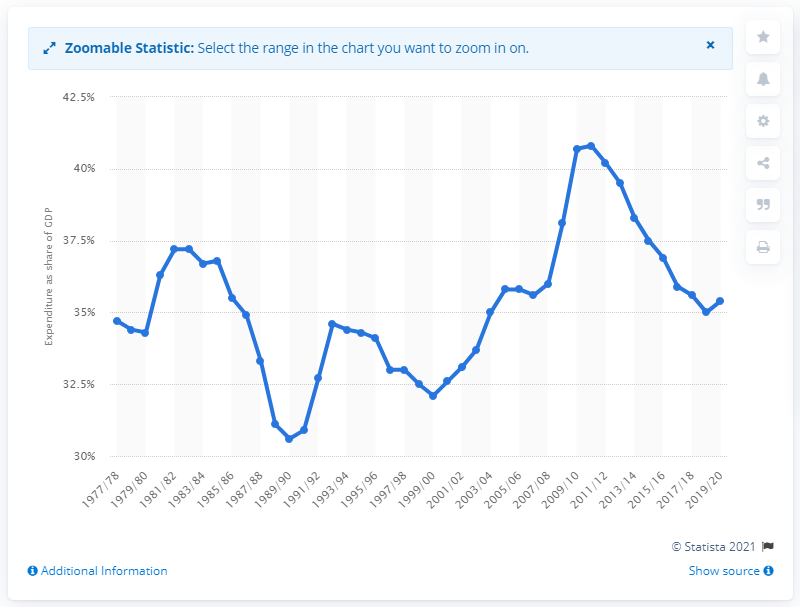Mention a couple of crucial points in this snapshot. In the 2019/20 fiscal year, the government expenditure in the UK accounted for approximately 35.4% of the country's gross domestic product. 